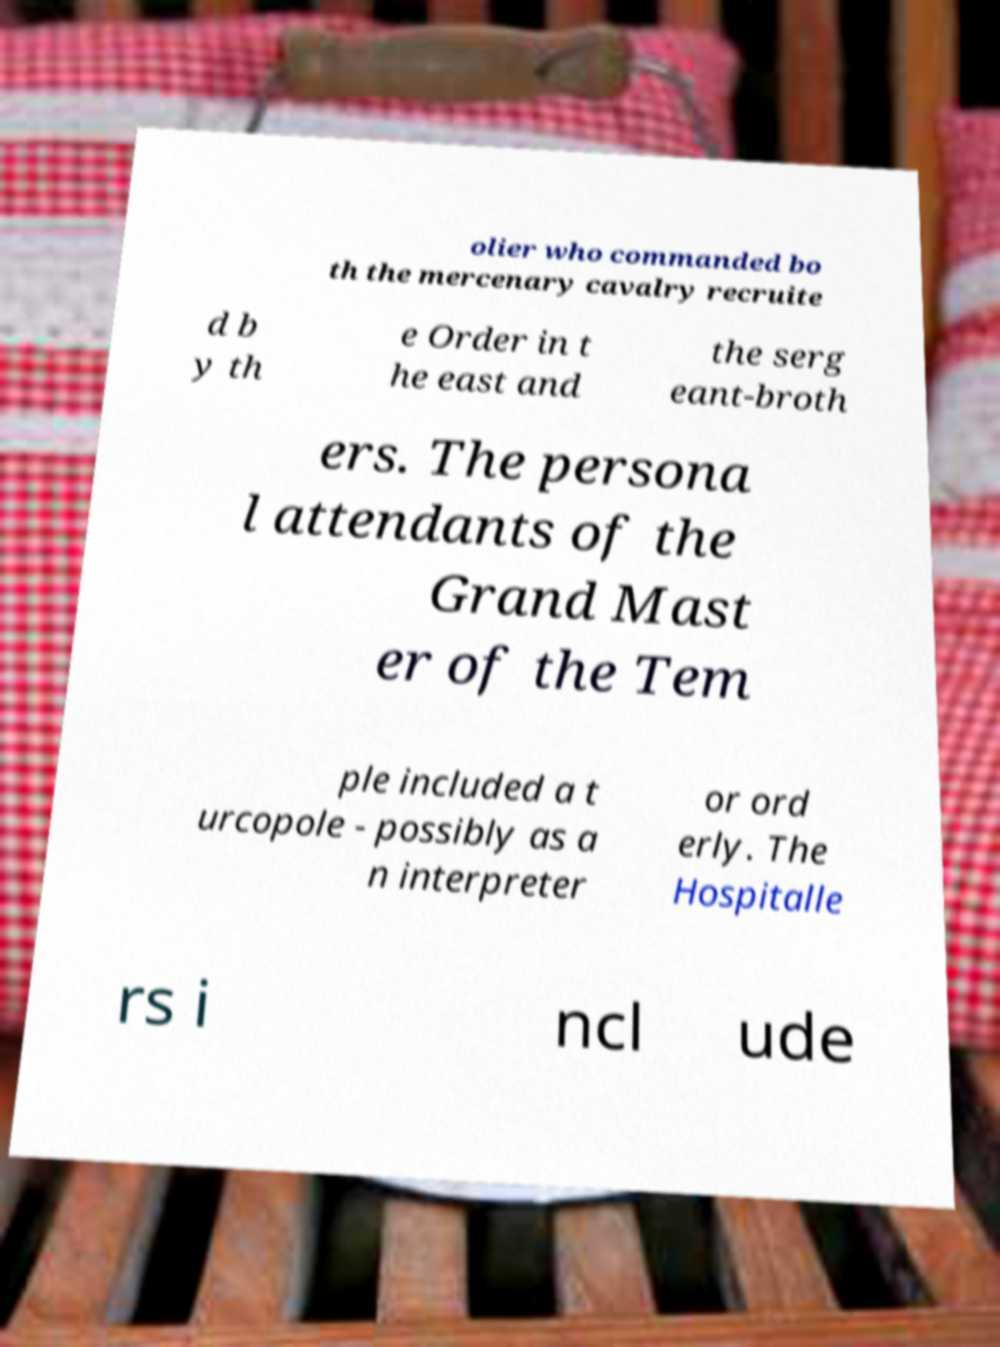Could you assist in decoding the text presented in this image and type it out clearly? olier who commanded bo th the mercenary cavalry recruite d b y th e Order in t he east and the serg eant-broth ers. The persona l attendants of the Grand Mast er of the Tem ple included a t urcopole - possibly as a n interpreter or ord erly. The Hospitalle rs i ncl ude 